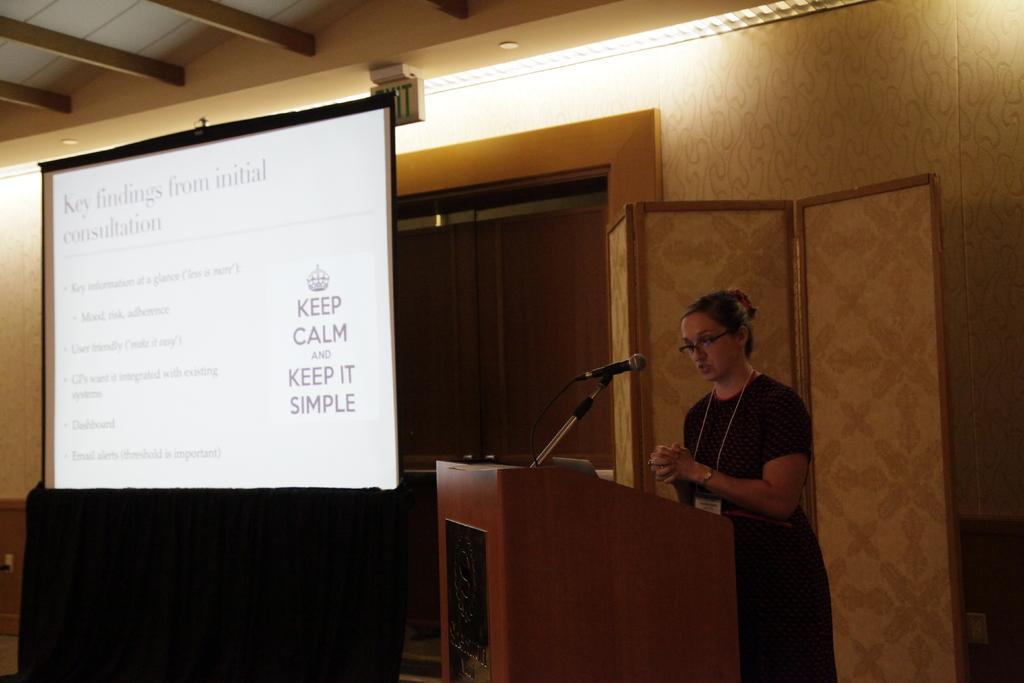Can you describe this image briefly? In the image there is a woman in black dress standing in front of dias talking on mic and beside her there is screen on the wall, there are lights over the ceiling. 